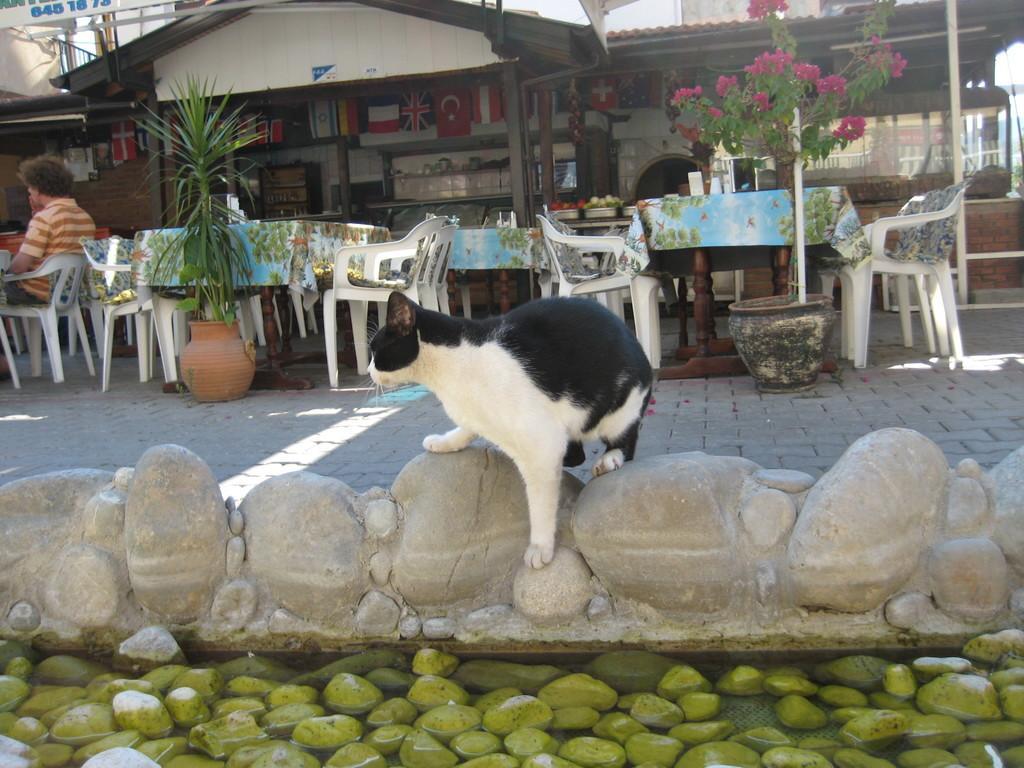Could you give a brief overview of what you see in this image? This is a cat standing. These are the rocks. I can see the water. Here is a person sitting on the chair. I can see the tables covered with the clothes. I think these are the flower pots with the plants in it. This looks like a restaurant. I can see the flags hanging. 